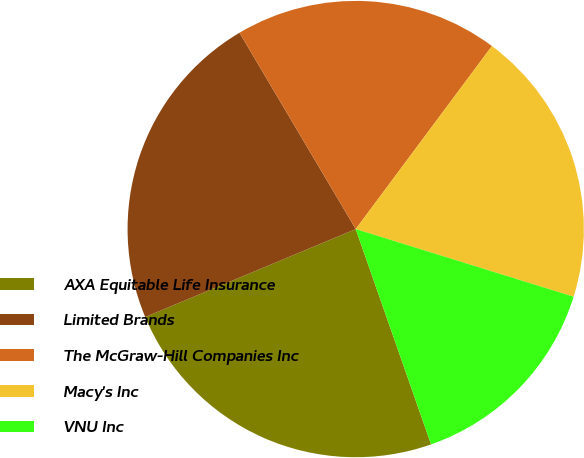Convert chart to OTSL. <chart><loc_0><loc_0><loc_500><loc_500><pie_chart><fcel>AXA Equitable Life Insurance<fcel>Limited Brands<fcel>The McGraw-Hill Companies Inc<fcel>Macy's Inc<fcel>VNU Inc<nl><fcel>24.06%<fcel>22.79%<fcel>18.69%<fcel>19.61%<fcel>14.85%<nl></chart> 